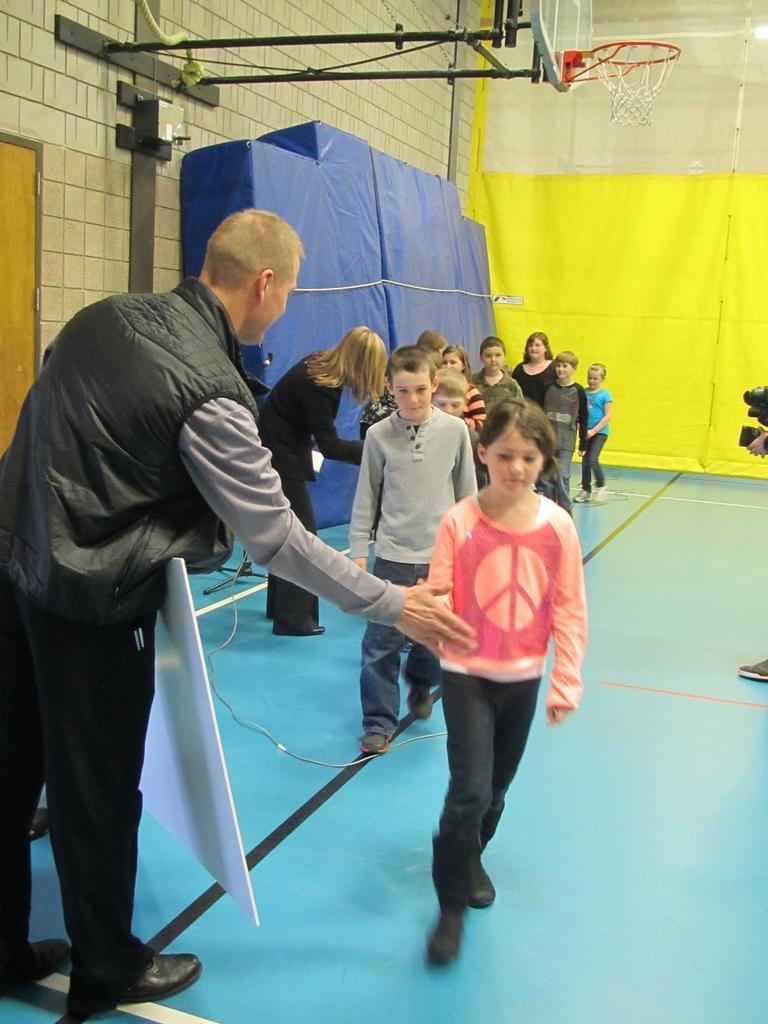Could you give a brief overview of what you see in this image? In this image there are persons standing and walking and there is a board which is white in colour. In the background there are curtains which are blue and yellow in colour and on the top there is a basketball net. On the right side there is a person holding a camera. On the left side there is a wall and there is a door. 